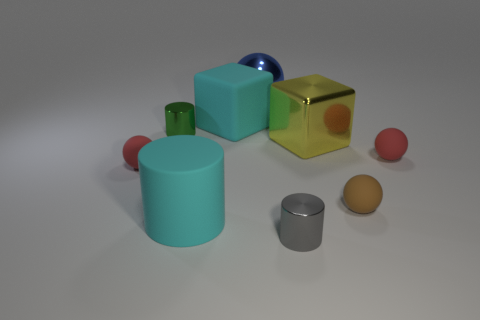There is a large thing that is the same color as the big cylinder; what is its material?
Offer a terse response. Rubber. What number of small brown rubber spheres are there?
Make the answer very short. 1. There is a red matte thing left of the yellow metal object; is it the same size as the small green object?
Make the answer very short. Yes. What number of matte objects are either big yellow cubes or big blocks?
Make the answer very short. 1. How many small red things are behind the tiny object on the left side of the tiny green shiny thing?
Provide a short and direct response. 1. The thing that is right of the tiny gray cylinder and left of the brown rubber object has what shape?
Provide a short and direct response. Cube. There is a small cylinder behind the red rubber sphere that is to the left of the cyan rubber object left of the rubber block; what is it made of?
Your answer should be compact. Metal. There is a object that is the same color as the large matte block; what is its size?
Ensure brevity in your answer.  Large. What is the material of the gray cylinder?
Make the answer very short. Metal. Do the small gray object and the big yellow block that is left of the brown thing have the same material?
Provide a succinct answer. Yes. 